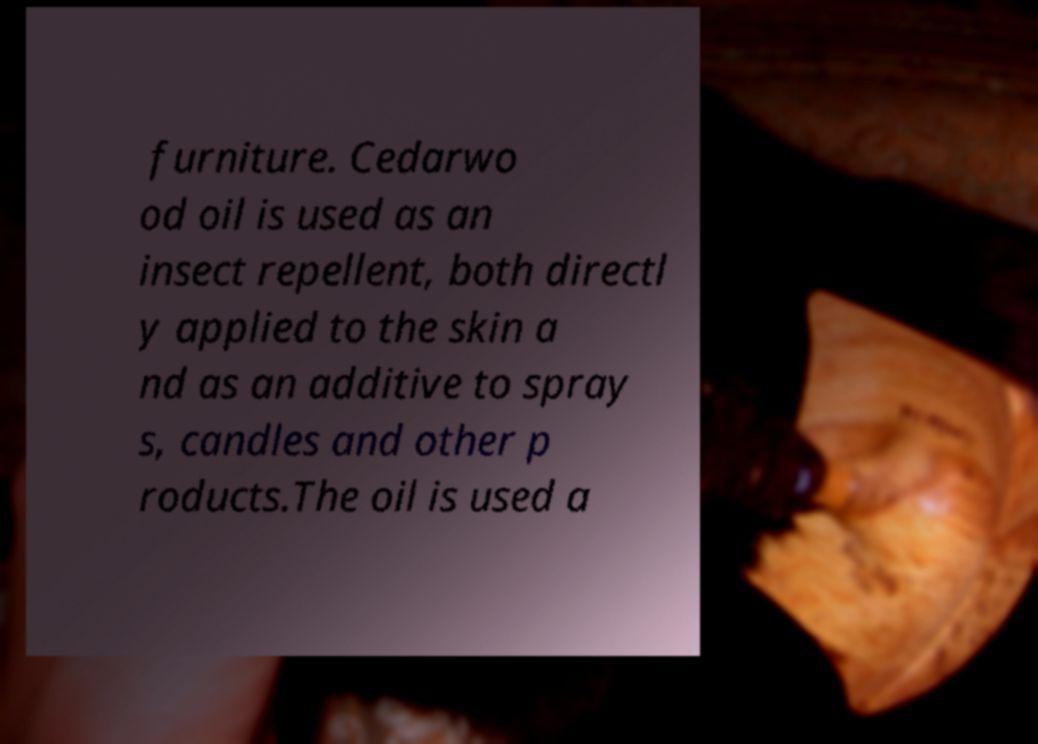Could you assist in decoding the text presented in this image and type it out clearly? furniture. Cedarwo od oil is used as an insect repellent, both directl y applied to the skin a nd as an additive to spray s, candles and other p roducts.The oil is used a 